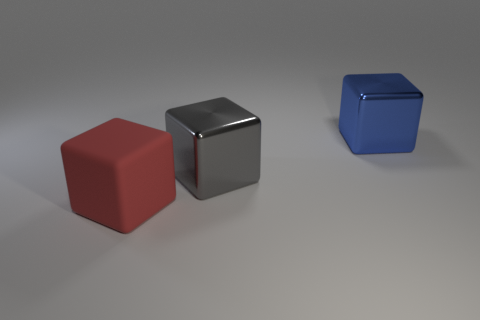Add 2 big gray rubber blocks. How many objects exist? 5 Subtract all rubber objects. Subtract all big red objects. How many objects are left? 1 Add 1 large red rubber things. How many large red rubber things are left? 2 Add 3 big blue objects. How many big blue objects exist? 4 Subtract 0 brown cylinders. How many objects are left? 3 